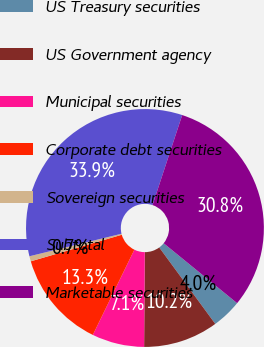<chart> <loc_0><loc_0><loc_500><loc_500><pie_chart><fcel>US Treasury securities<fcel>US Government agency<fcel>Municipal securities<fcel>Corporate debt securities<fcel>Sovereign securities<fcel>Subtotal<fcel>Marketable securities<nl><fcel>4.04%<fcel>10.18%<fcel>7.11%<fcel>13.26%<fcel>0.7%<fcel>33.89%<fcel>30.82%<nl></chart> 